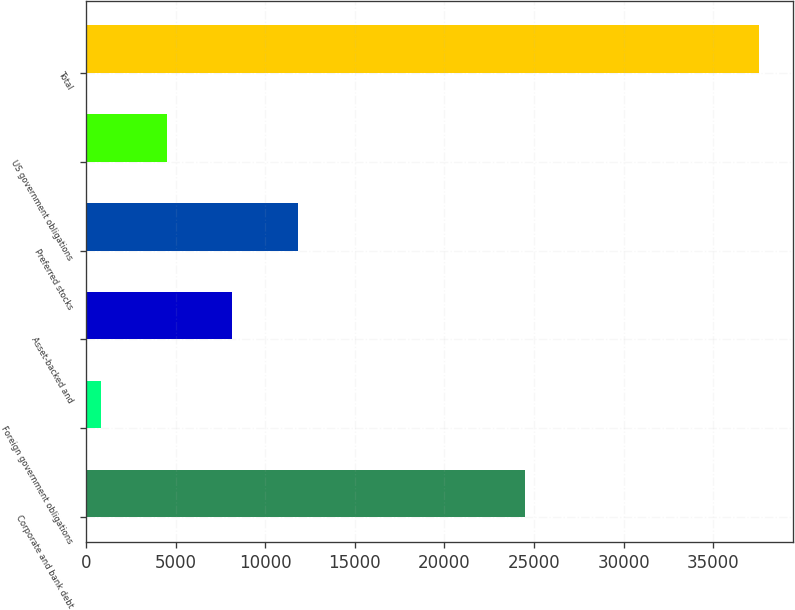<chart> <loc_0><loc_0><loc_500><loc_500><bar_chart><fcel>Corporate and bank debt<fcel>Foreign government obligations<fcel>Asset-backed and<fcel>Preferred stocks<fcel>US government obligations<fcel>Total<nl><fcel>24496<fcel>825<fcel>8174.4<fcel>11849.1<fcel>4499.7<fcel>37572<nl></chart> 